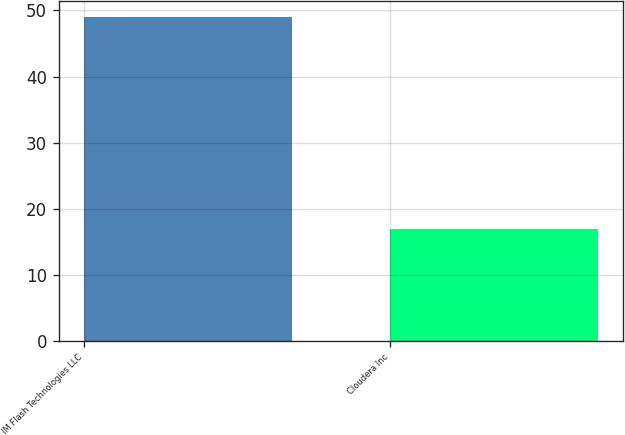Convert chart to OTSL. <chart><loc_0><loc_0><loc_500><loc_500><bar_chart><fcel>IM Flash Technologies LLC<fcel>Cloudera Inc<nl><fcel>49<fcel>17<nl></chart> 